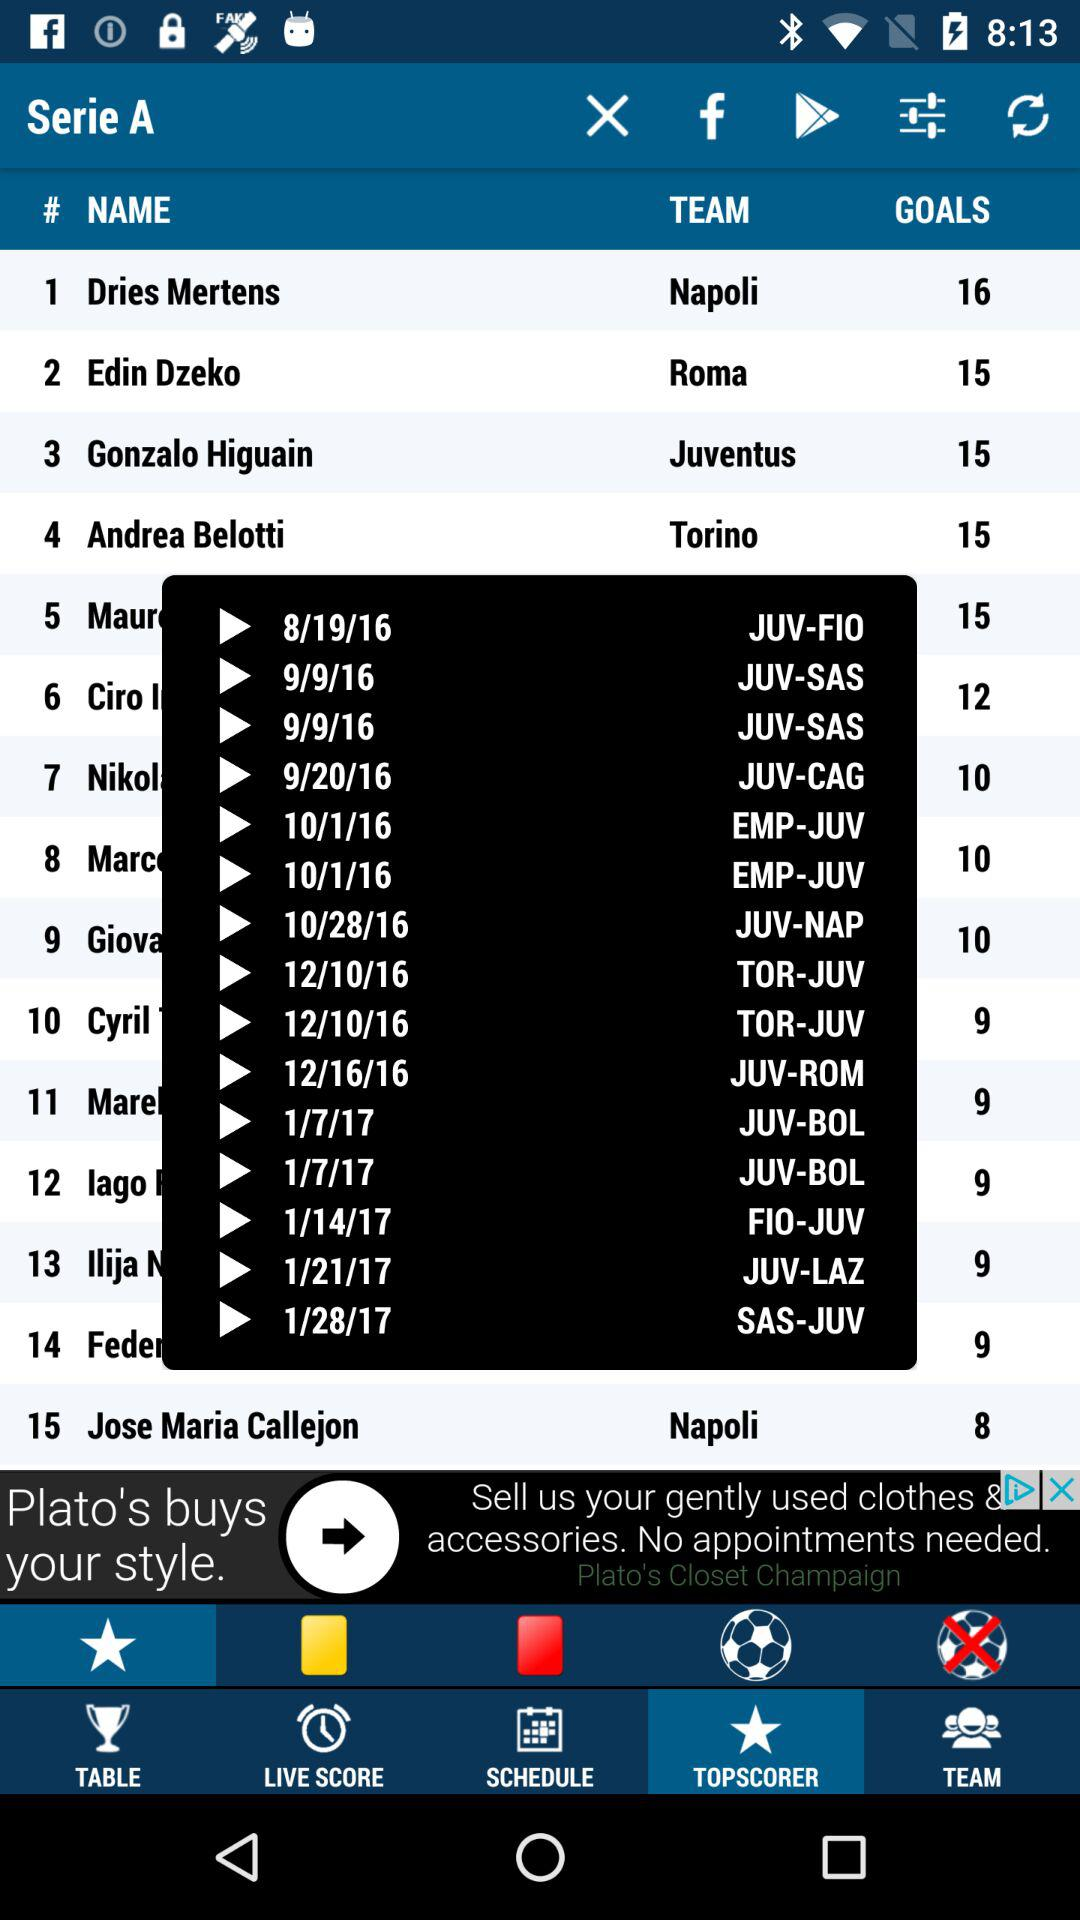Which team does Edin Dzeko play for? Edin Dzeko plays for "Roma". 